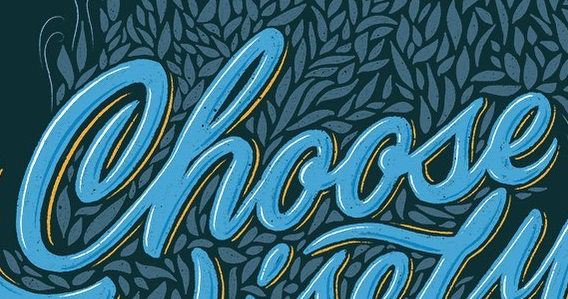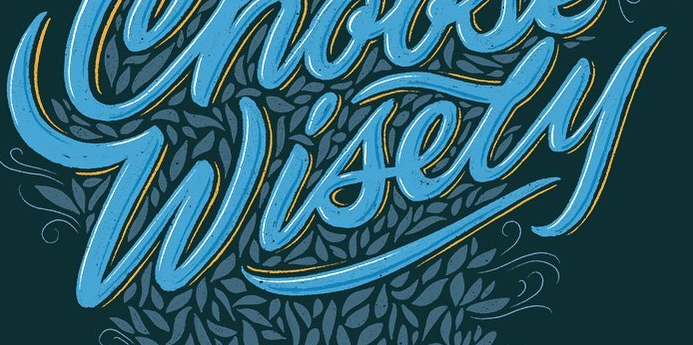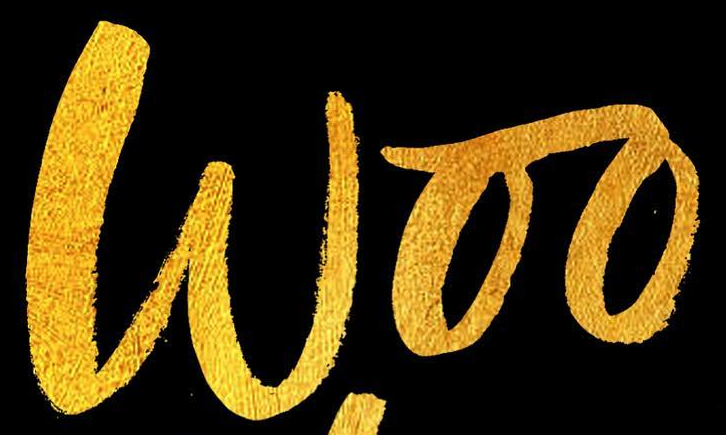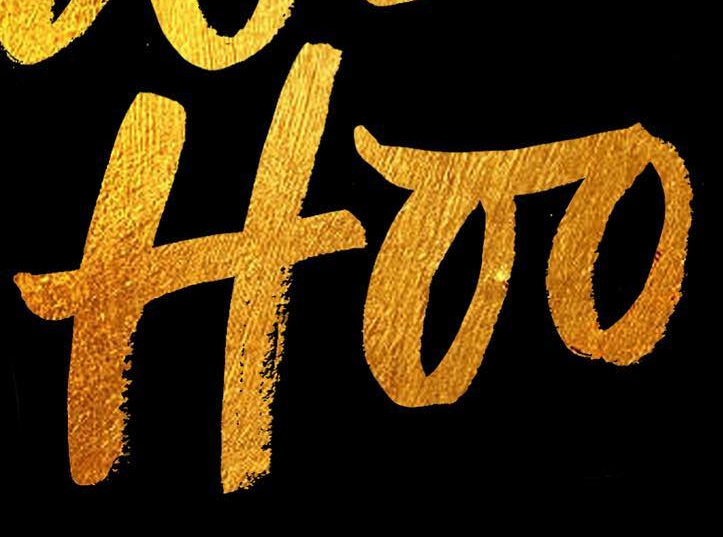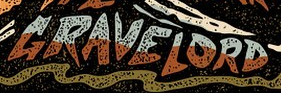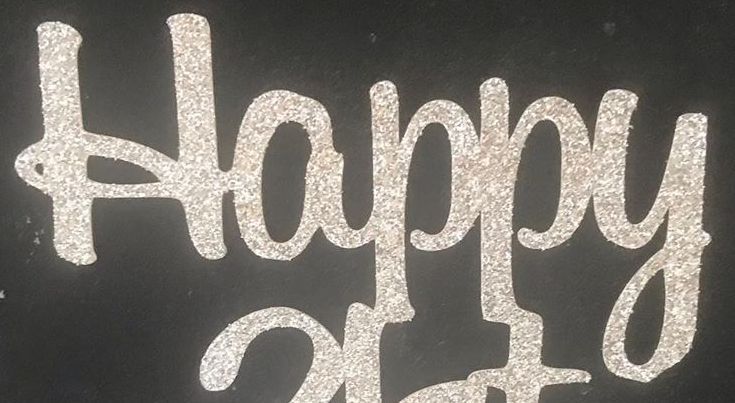What words are shown in these images in order, separated by a semicolon? Choose; Wisely; Woo; Hoo; GRAVELORD; Happy 